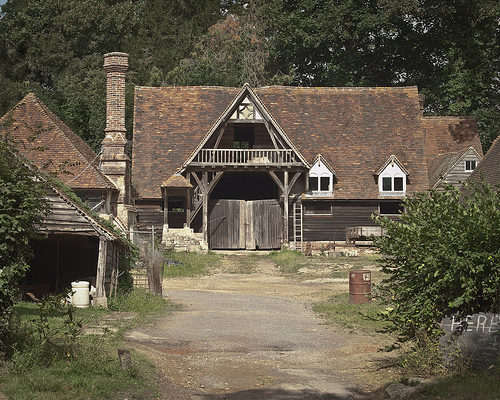<image>
Can you confirm if the bush is behind the house? No. The bush is not behind the house. From this viewpoint, the bush appears to be positioned elsewhere in the scene. 